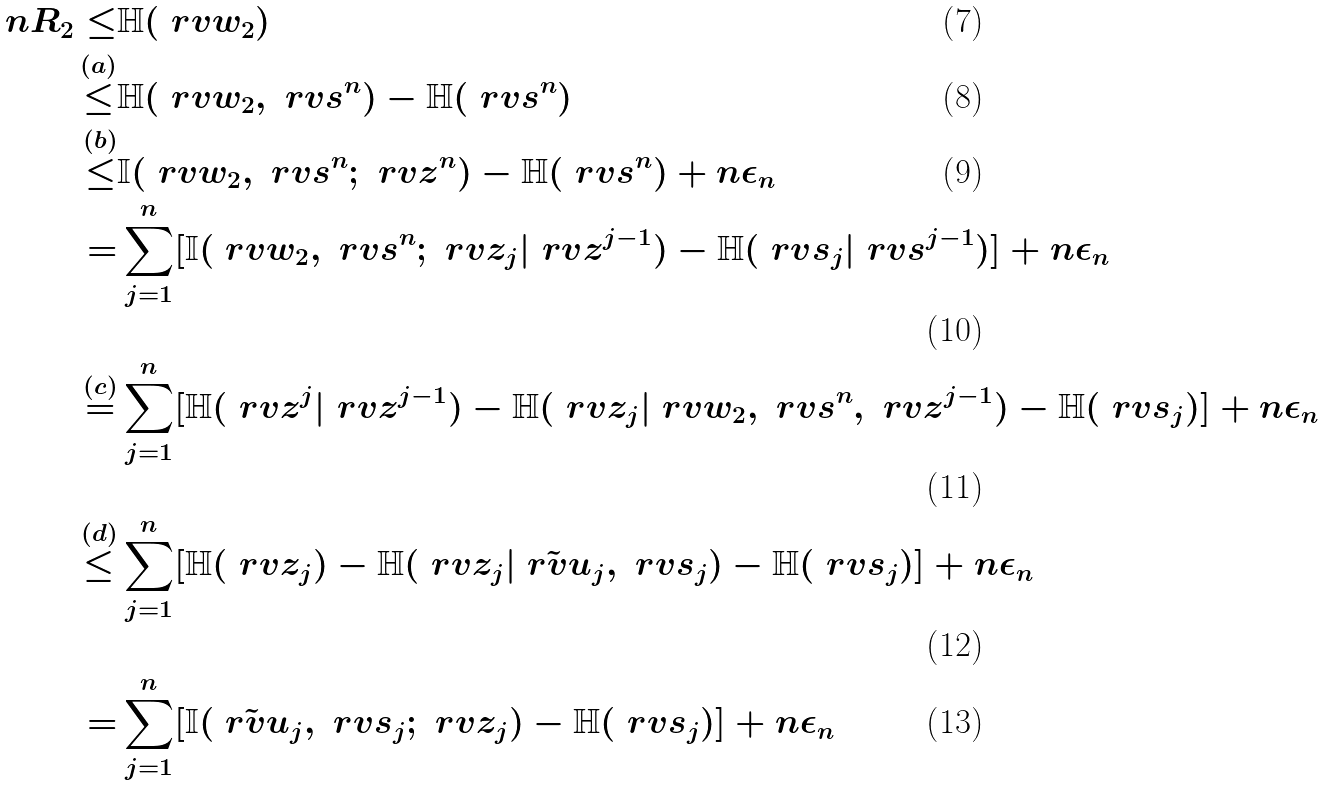<formula> <loc_0><loc_0><loc_500><loc_500>n R _ { 2 } \leq & \mathbb { H } ( \ r v w _ { 2 } ) \\ \stackrel { ( a ) } { \leq } & \mathbb { H } ( \ r v w _ { 2 } , \ r v s ^ { n } ) - \mathbb { H } ( \ r v s ^ { n } ) \\ \stackrel { ( b ) } { \leq } & \mathbb { I } ( \ r v w _ { 2 } , \ r v s ^ { n } ; \ r v z ^ { n } ) - \mathbb { H } ( \ r v s ^ { n } ) + n \epsilon _ { n } \\ = & \sum _ { j = 1 } ^ { n } [ \mathbb { I } ( \ r v w _ { 2 } , \ r v s ^ { n } ; \ r v z _ { j } | \ r v z ^ { j - 1 } ) - \mathbb { H } ( \ r v s _ { j } | \ r v s ^ { j - 1 } ) ] + n \epsilon _ { n } \\ \stackrel { ( c ) } { = } & \sum _ { j = 1 } ^ { n } [ \mathbb { H } ( \ r v z ^ { j } | \ r v z ^ { j - 1 } ) - \mathbb { H } ( \ r v z _ { j } | \ r v w _ { 2 } , \ r v s ^ { n } , \ r v z ^ { j - 1 } ) - \mathbb { H } ( \ r v s _ { j } ) ] + n \epsilon _ { n } \\ \stackrel { ( d ) } { \leq } & \sum _ { j = 1 } ^ { n } [ \mathbb { H } ( \ r v z _ { j } ) - \mathbb { H } ( \ r v z _ { j } | \tilde { \ r v u } _ { j } , \ r v s _ { j } ) - \mathbb { H } ( \ r v s _ { j } ) ] + n \epsilon _ { n } \\ = & \sum _ { j = 1 } ^ { n } [ \mathbb { I } ( \tilde { \ r v u } _ { j } , \ r v s _ { j } ; \ r v z _ { j } ) - \mathbb { H } ( \ r v s _ { j } ) ] + n \epsilon _ { n }</formula> 